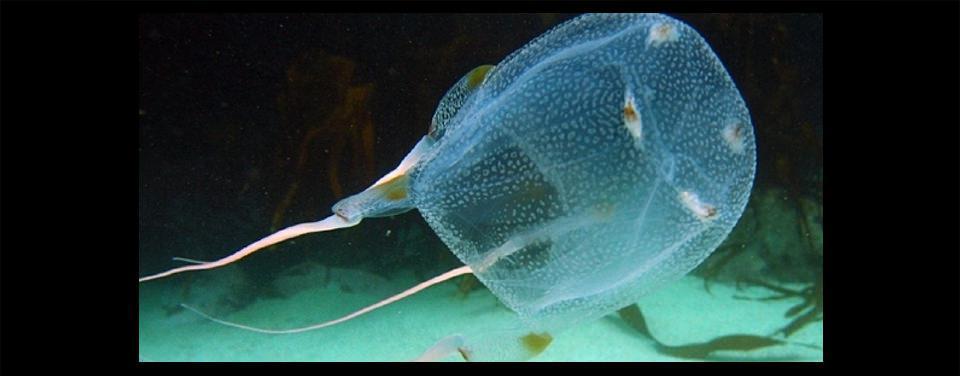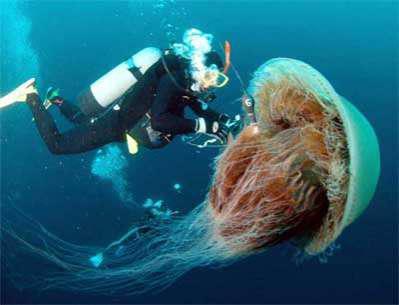The first image is the image on the left, the second image is the image on the right. Given the left and right images, does the statement "There is a scuba diver with an airtank swimming with a jellyfish." hold true? Answer yes or no. Yes. 